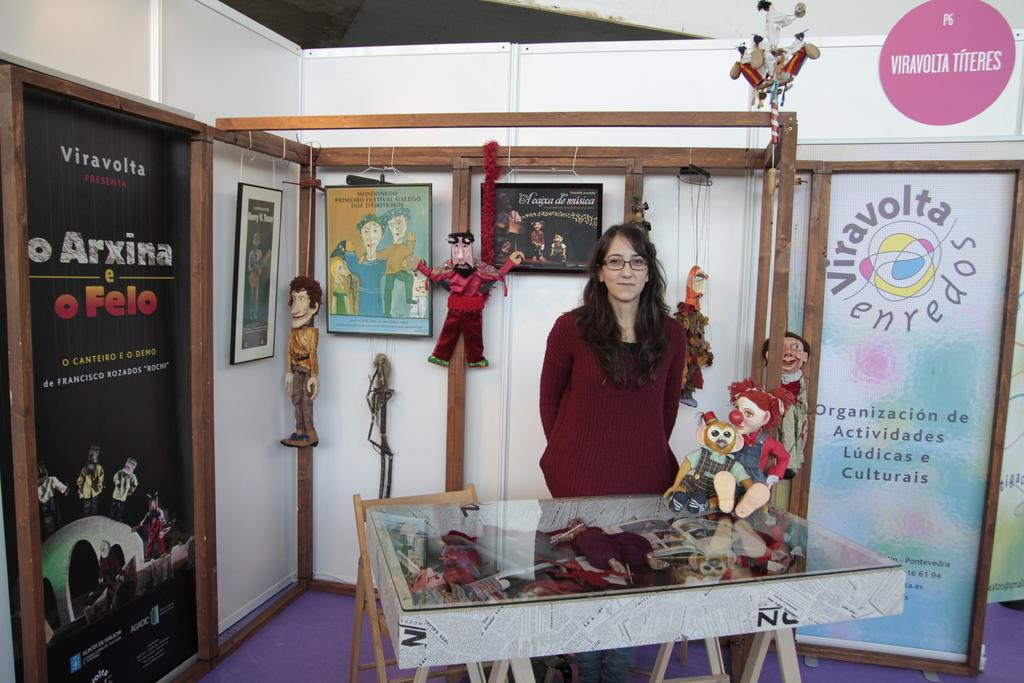What is the main subject in the image? There is a woman standing in the image. What else can be seen in the image besides the woman? There are toys on the table and on the wall in the image. What is visible in the background of the image? There are banners visible in the background of the image. Where is the mine located in the image? There is no mine present in the image. What type of tray is being used to hold the toys on the table? There is no tray visible in the image; the toys are directly on the table. 